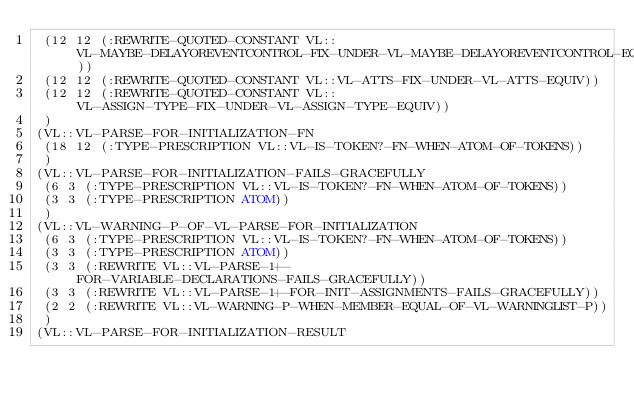<code> <loc_0><loc_0><loc_500><loc_500><_Lisp_> (12 12 (:REWRITE-QUOTED-CONSTANT VL::VL-MAYBE-DELAYOREVENTCONTROL-FIX-UNDER-VL-MAYBE-DELAYOREVENTCONTROL-EQUIV))
 (12 12 (:REWRITE-QUOTED-CONSTANT VL::VL-ATTS-FIX-UNDER-VL-ATTS-EQUIV))
 (12 12 (:REWRITE-QUOTED-CONSTANT VL::VL-ASSIGN-TYPE-FIX-UNDER-VL-ASSIGN-TYPE-EQUIV))
 )
(VL::VL-PARSE-FOR-INITIALIZATION-FN
 (18 12 (:TYPE-PRESCRIPTION VL::VL-IS-TOKEN?-FN-WHEN-ATOM-OF-TOKENS))
 )
(VL::VL-PARSE-FOR-INITIALIZATION-FAILS-GRACEFULLY
 (6 3 (:TYPE-PRESCRIPTION VL::VL-IS-TOKEN?-FN-WHEN-ATOM-OF-TOKENS))
 (3 3 (:TYPE-PRESCRIPTION ATOM))
 )
(VL::VL-WARNING-P-OF-VL-PARSE-FOR-INITIALIZATION
 (6 3 (:TYPE-PRESCRIPTION VL::VL-IS-TOKEN?-FN-WHEN-ATOM-OF-TOKENS))
 (3 3 (:TYPE-PRESCRIPTION ATOM))
 (3 3 (:REWRITE VL::VL-PARSE-1+-FOR-VARIABLE-DECLARATIONS-FAILS-GRACEFULLY))
 (3 3 (:REWRITE VL::VL-PARSE-1+-FOR-INIT-ASSIGNMENTS-FAILS-GRACEFULLY))
 (2 2 (:REWRITE VL::VL-WARNING-P-WHEN-MEMBER-EQUAL-OF-VL-WARNINGLIST-P))
 )
(VL::VL-PARSE-FOR-INITIALIZATION-RESULT</code> 